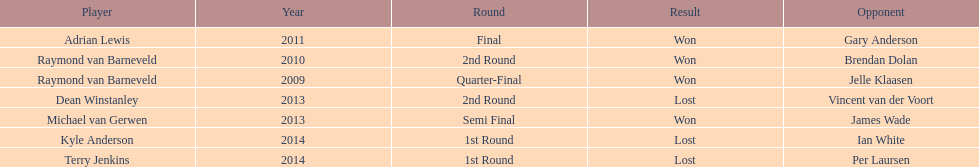Name a year with more than one game listed. 2013. Could you help me parse every detail presented in this table? {'header': ['Player', 'Year', 'Round', 'Result', 'Opponent'], 'rows': [['Adrian Lewis', '2011', 'Final', 'Won', 'Gary Anderson'], ['Raymond van Barneveld', '2010', '2nd Round', 'Won', 'Brendan Dolan'], ['Raymond van Barneveld', '2009', 'Quarter-Final', 'Won', 'Jelle Klaasen'], ['Dean Winstanley', '2013', '2nd Round', 'Lost', 'Vincent van der Voort'], ['Michael van Gerwen', '2013', 'Semi Final', 'Won', 'James Wade'], ['Kyle Anderson', '2014', '1st Round', 'Lost', 'Ian White'], ['Terry Jenkins', '2014', '1st Round', 'Lost', 'Per Laursen']]} 